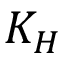Convert formula to latex. <formula><loc_0><loc_0><loc_500><loc_500>K _ { H }</formula> 